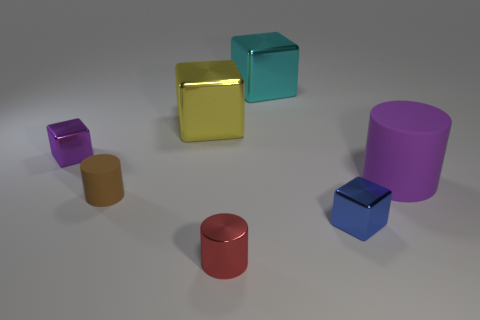What number of rubber objects are tiny brown objects or tiny cylinders?
Your response must be concise. 1. There is a shiny object on the left side of the tiny matte thing; is its shape the same as the rubber object in front of the big purple cylinder?
Your answer should be compact. No. Are there any brown things made of the same material as the cyan cube?
Ensure brevity in your answer.  No. The large cylinder is what color?
Ensure brevity in your answer.  Purple. There is a matte thing that is on the left side of the big yellow shiny object; what size is it?
Provide a succinct answer. Small. How many big rubber objects have the same color as the tiny shiny cylinder?
Offer a very short reply. 0. Is there a metallic block to the left of the large metallic block right of the small metallic cylinder?
Offer a very short reply. Yes. Do the metallic cube that is behind the large yellow thing and the small metal block right of the small red metal cylinder have the same color?
Make the answer very short. No. There is a metal cylinder that is the same size as the blue shiny cube; what color is it?
Make the answer very short. Red. Is the number of cylinders on the left side of the red metal cylinder the same as the number of yellow metal objects to the right of the yellow shiny object?
Ensure brevity in your answer.  No. 